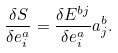<formula> <loc_0><loc_0><loc_500><loc_500>\frac { \delta S } { \delta e _ { i } ^ { a } } = \frac { \delta E ^ { b j } } { \delta e _ { i } ^ { a } } a _ { j } ^ { b } .</formula> 